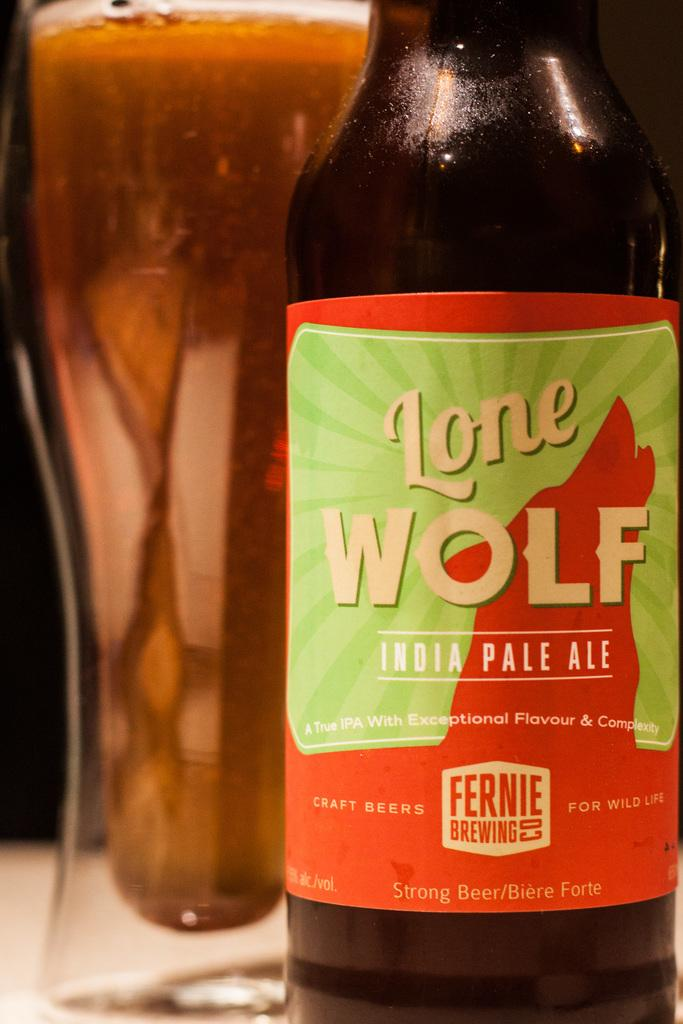<image>
Create a compact narrative representing the image presented. An Indian pale ale called Lone Wolf on a table 